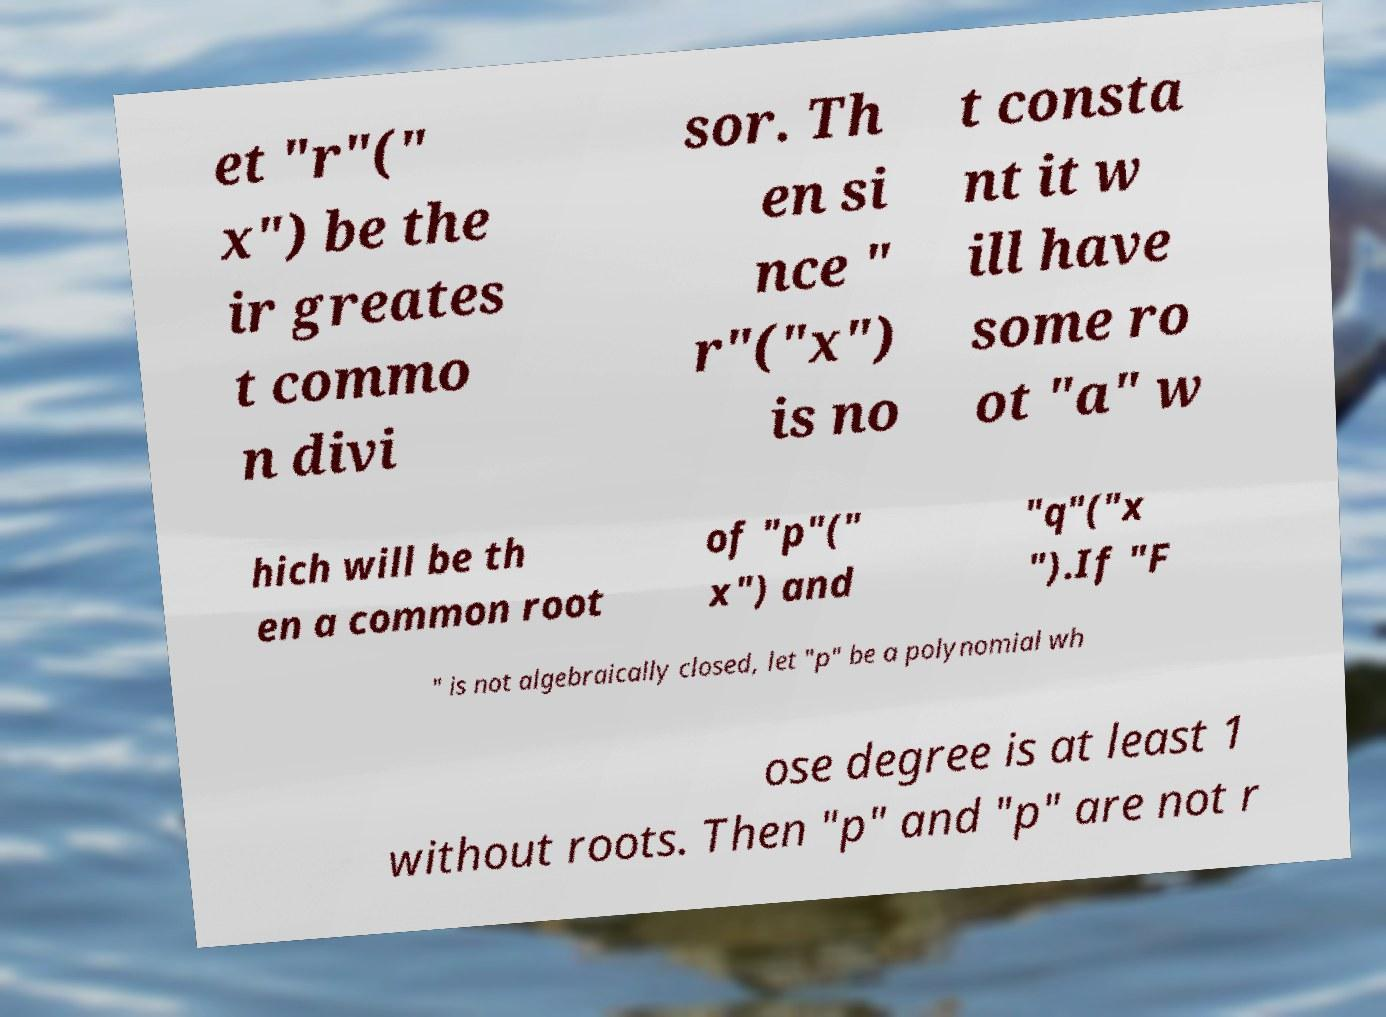Can you read and provide the text displayed in the image?This photo seems to have some interesting text. Can you extract and type it out for me? et "r"(" x") be the ir greates t commo n divi sor. Th en si nce " r"("x") is no t consta nt it w ill have some ro ot "a" w hich will be th en a common root of "p"(" x") and "q"("x ").If "F " is not algebraically closed, let "p" be a polynomial wh ose degree is at least 1 without roots. Then "p" and "p" are not r 